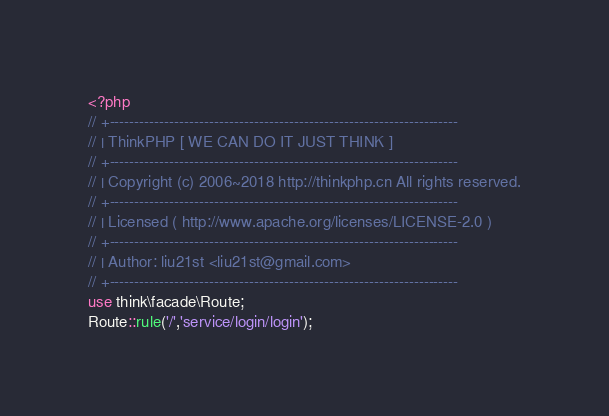Convert code to text. <code><loc_0><loc_0><loc_500><loc_500><_PHP_><?php
// +----------------------------------------------------------------------
// | ThinkPHP [ WE CAN DO IT JUST THINK ]
// +----------------------------------------------------------------------
// | Copyright (c) 2006~2018 http://thinkphp.cn All rights reserved.
// +----------------------------------------------------------------------
// | Licensed ( http://www.apache.org/licenses/LICENSE-2.0 )
// +----------------------------------------------------------------------
// | Author: liu21st <liu21st@gmail.com>
// +----------------------------------------------------------------------
use think\facade\Route;
Route::rule('/','service/login/login');</code> 